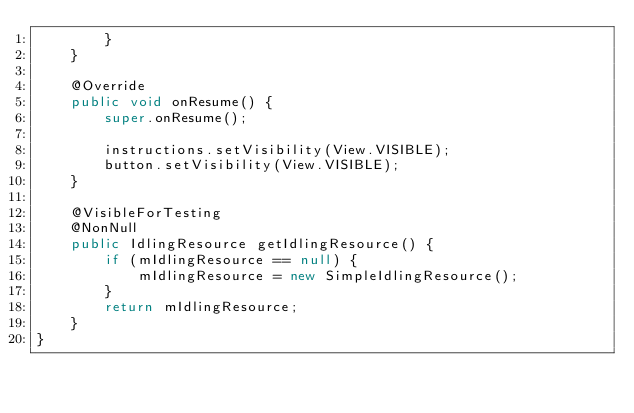Convert code to text. <code><loc_0><loc_0><loc_500><loc_500><_Java_>        }
    }

    @Override
    public void onResume() {
        super.onResume();

        instructions.setVisibility(View.VISIBLE);
        button.setVisibility(View.VISIBLE);
    }

    @VisibleForTesting
    @NonNull
    public IdlingResource getIdlingResource() {
        if (mIdlingResource == null) {
            mIdlingResource = new SimpleIdlingResource();
        }
        return mIdlingResource;
    }
}</code> 